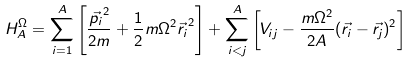<formula> <loc_0><loc_0><loc_500><loc_500>H _ { A } ^ { \Omega } = \sum _ { i = 1 } ^ { A } \left [ \frac { \vec { p _ { i } } ^ { 2 } } { 2 m } + \frac { 1 } { 2 } m \Omega ^ { 2 } \vec { r _ { i } } ^ { 2 } \right ] + \sum _ { i < j } ^ { A } \left [ V _ { i j } - \frac { m \Omega ^ { 2 } } { 2 A } ( \vec { r _ { i } } - \vec { r _ { j } } ) ^ { 2 } \right ]</formula> 